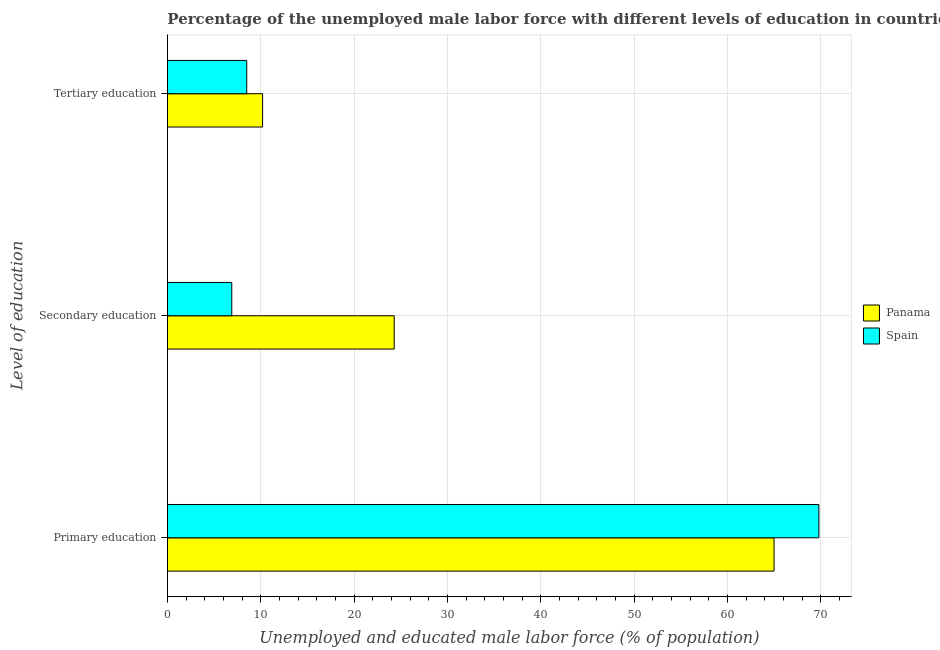How many bars are there on the 3rd tick from the top?
Your answer should be very brief. 2. How many bars are there on the 2nd tick from the bottom?
Ensure brevity in your answer.  2. What is the label of the 1st group of bars from the top?
Your answer should be compact. Tertiary education. What is the percentage of male labor force who received tertiary education in Panama?
Give a very brief answer. 10.2. Across all countries, what is the maximum percentage of male labor force who received tertiary education?
Make the answer very short. 10.2. Across all countries, what is the minimum percentage of male labor force who received secondary education?
Provide a short and direct response. 6.9. In which country was the percentage of male labor force who received primary education maximum?
Offer a terse response. Spain. In which country was the percentage of male labor force who received tertiary education minimum?
Offer a terse response. Spain. What is the total percentage of male labor force who received secondary education in the graph?
Offer a terse response. 31.2. What is the difference between the percentage of male labor force who received tertiary education in Spain and that in Panama?
Offer a terse response. -1.7. What is the difference between the percentage of male labor force who received tertiary education in Spain and the percentage of male labor force who received primary education in Panama?
Keep it short and to the point. -56.5. What is the average percentage of male labor force who received primary education per country?
Offer a very short reply. 67.4. What is the difference between the percentage of male labor force who received secondary education and percentage of male labor force who received tertiary education in Spain?
Your answer should be compact. -1.6. In how many countries, is the percentage of male labor force who received secondary education greater than 66 %?
Provide a succinct answer. 0. What is the ratio of the percentage of male labor force who received primary education in Spain to that in Panama?
Your answer should be compact. 1.07. What is the difference between the highest and the second highest percentage of male labor force who received secondary education?
Keep it short and to the point. 17.4. What is the difference between the highest and the lowest percentage of male labor force who received tertiary education?
Your answer should be very brief. 1.7. What does the 2nd bar from the top in Tertiary education represents?
Your answer should be compact. Panama. What does the 1st bar from the bottom in Tertiary education represents?
Offer a terse response. Panama. How many bars are there?
Your answer should be very brief. 6. Are all the bars in the graph horizontal?
Your answer should be compact. Yes. Are the values on the major ticks of X-axis written in scientific E-notation?
Your answer should be compact. No. Does the graph contain any zero values?
Give a very brief answer. No. Does the graph contain grids?
Keep it short and to the point. Yes. What is the title of the graph?
Offer a terse response. Percentage of the unemployed male labor force with different levels of education in countries. What is the label or title of the X-axis?
Your answer should be very brief. Unemployed and educated male labor force (% of population). What is the label or title of the Y-axis?
Your answer should be compact. Level of education. What is the Unemployed and educated male labor force (% of population) in Panama in Primary education?
Ensure brevity in your answer.  65. What is the Unemployed and educated male labor force (% of population) in Spain in Primary education?
Your answer should be compact. 69.8. What is the Unemployed and educated male labor force (% of population) in Panama in Secondary education?
Your answer should be very brief. 24.3. What is the Unemployed and educated male labor force (% of population) of Spain in Secondary education?
Provide a succinct answer. 6.9. What is the Unemployed and educated male labor force (% of population) of Panama in Tertiary education?
Make the answer very short. 10.2. What is the Unemployed and educated male labor force (% of population) in Spain in Tertiary education?
Offer a very short reply. 8.5. Across all Level of education, what is the maximum Unemployed and educated male labor force (% of population) in Spain?
Ensure brevity in your answer.  69.8. Across all Level of education, what is the minimum Unemployed and educated male labor force (% of population) of Panama?
Provide a short and direct response. 10.2. Across all Level of education, what is the minimum Unemployed and educated male labor force (% of population) in Spain?
Offer a terse response. 6.9. What is the total Unemployed and educated male labor force (% of population) of Panama in the graph?
Ensure brevity in your answer.  99.5. What is the total Unemployed and educated male labor force (% of population) of Spain in the graph?
Offer a very short reply. 85.2. What is the difference between the Unemployed and educated male labor force (% of population) of Panama in Primary education and that in Secondary education?
Offer a terse response. 40.7. What is the difference between the Unemployed and educated male labor force (% of population) in Spain in Primary education and that in Secondary education?
Your answer should be compact. 62.9. What is the difference between the Unemployed and educated male labor force (% of population) of Panama in Primary education and that in Tertiary education?
Provide a short and direct response. 54.8. What is the difference between the Unemployed and educated male labor force (% of population) of Spain in Primary education and that in Tertiary education?
Your answer should be compact. 61.3. What is the difference between the Unemployed and educated male labor force (% of population) of Panama in Primary education and the Unemployed and educated male labor force (% of population) of Spain in Secondary education?
Offer a terse response. 58.1. What is the difference between the Unemployed and educated male labor force (% of population) in Panama in Primary education and the Unemployed and educated male labor force (% of population) in Spain in Tertiary education?
Offer a terse response. 56.5. What is the average Unemployed and educated male labor force (% of population) in Panama per Level of education?
Your answer should be very brief. 33.17. What is the average Unemployed and educated male labor force (% of population) in Spain per Level of education?
Your answer should be very brief. 28.4. What is the difference between the Unemployed and educated male labor force (% of population) of Panama and Unemployed and educated male labor force (% of population) of Spain in Primary education?
Provide a short and direct response. -4.8. What is the difference between the Unemployed and educated male labor force (% of population) of Panama and Unemployed and educated male labor force (% of population) of Spain in Secondary education?
Ensure brevity in your answer.  17.4. What is the ratio of the Unemployed and educated male labor force (% of population) of Panama in Primary education to that in Secondary education?
Provide a succinct answer. 2.67. What is the ratio of the Unemployed and educated male labor force (% of population) of Spain in Primary education to that in Secondary education?
Keep it short and to the point. 10.12. What is the ratio of the Unemployed and educated male labor force (% of population) in Panama in Primary education to that in Tertiary education?
Offer a very short reply. 6.37. What is the ratio of the Unemployed and educated male labor force (% of population) of Spain in Primary education to that in Tertiary education?
Provide a short and direct response. 8.21. What is the ratio of the Unemployed and educated male labor force (% of population) of Panama in Secondary education to that in Tertiary education?
Provide a succinct answer. 2.38. What is the ratio of the Unemployed and educated male labor force (% of population) in Spain in Secondary education to that in Tertiary education?
Your answer should be compact. 0.81. What is the difference between the highest and the second highest Unemployed and educated male labor force (% of population) of Panama?
Your response must be concise. 40.7. What is the difference between the highest and the second highest Unemployed and educated male labor force (% of population) of Spain?
Offer a very short reply. 61.3. What is the difference between the highest and the lowest Unemployed and educated male labor force (% of population) of Panama?
Give a very brief answer. 54.8. What is the difference between the highest and the lowest Unemployed and educated male labor force (% of population) of Spain?
Provide a short and direct response. 62.9. 